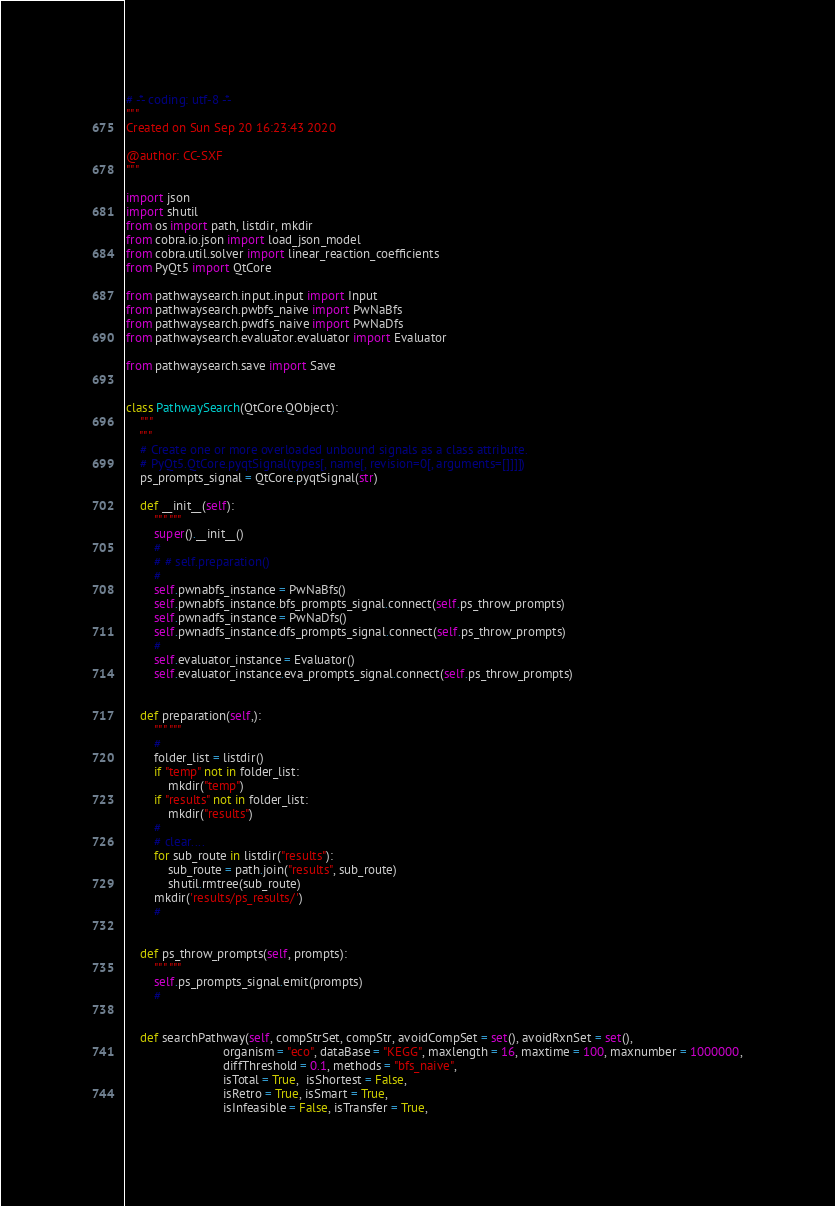<code> <loc_0><loc_0><loc_500><loc_500><_Python_># -*- coding: utf-8 -*-
"""
Created on Sun Sep 20 16:23:43 2020

@author: CC-SXF
"""

import json
import shutil
from os import path, listdir, mkdir
from cobra.io.json import load_json_model
from cobra.util.solver import linear_reaction_coefficients
from PyQt5 import QtCore

from pathwaysearch.input.input import Input
from pathwaysearch.pwbfs_naive import PwNaBfs
from pathwaysearch.pwdfs_naive import PwNaDfs
from pathwaysearch.evaluator.evaluator import Evaluator

from pathwaysearch.save import Save


class PathwaySearch(QtCore.QObject):
    """
    """
    # Create one or more overloaded unbound signals as a class attribute.
    # PyQt5.QtCore.pyqtSignal(types[, name[, revision=0[, arguments=[]]]])
    ps_prompts_signal = QtCore.pyqtSignal(str)

    def __init__(self):
        """ """
        super().__init__()
        #
        # # self.preparation()
        #
        self.pwnabfs_instance = PwNaBfs()
        self.pwnabfs_instance.bfs_prompts_signal.connect(self.ps_throw_prompts)
        self.pwnadfs_instance = PwNaDfs()
        self.pwnadfs_instance.dfs_prompts_signal.connect(self.ps_throw_prompts)
        #
        self.evaluator_instance = Evaluator()
        self.evaluator_instance.eva_prompts_signal.connect(self.ps_throw_prompts)


    def preparation(self,):
        """ """
        #
        folder_list = listdir()
        if "temp" not in folder_list:
            mkdir("temp")
        if "results" not in folder_list:
            mkdir("results")
        #
        # clear....
        for sub_route in listdir("results"):
            sub_route = path.join("results", sub_route)
            shutil.rmtree(sub_route)
        mkdir('results/ps_results/')
        #


    def ps_throw_prompts(self, prompts):
        """ """
        self.ps_prompts_signal.emit(prompts)
        #


    def searchPathway(self, compStrSet, compStr, avoidCompSet = set(), avoidRxnSet = set(),
                            organism = "eco", dataBase = "KEGG", maxlength = 16, maxtime = 100, maxnumber = 1000000,
                            diffThreshold = 0.1, methods = "bfs_naive",
                            isTotal = True,  isShortest = False,
                            isRetro = True, isSmart = True,
                            isInfeasible = False, isTransfer = True,</code> 